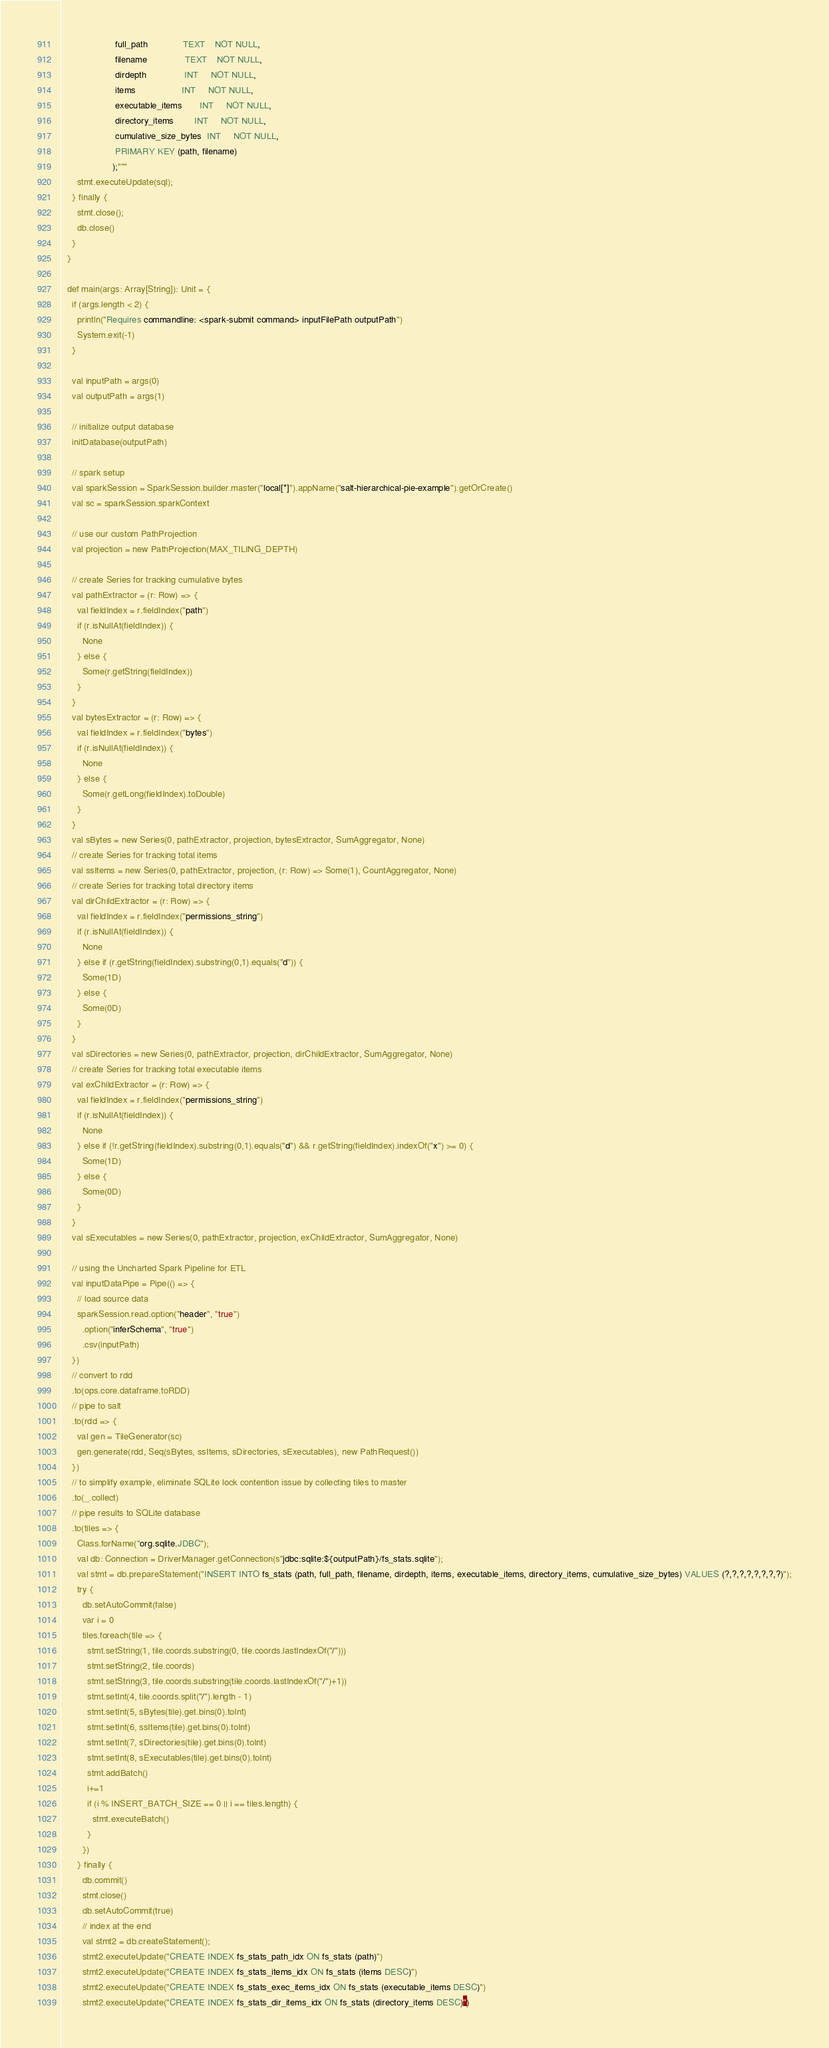Convert code to text. <code><loc_0><loc_0><loc_500><loc_500><_Scala_>                     full_path              TEXT    NOT NULL,
                     filename               TEXT    NOT NULL,
                     dirdepth               INT     NOT NULL,
                     items                  INT     NOT NULL,
                     executable_items       INT     NOT NULL,
                     directory_items        INT     NOT NULL,
                     cumulative_size_bytes  INT     NOT NULL,
                     PRIMARY KEY (path, filename)
                    );"""
      stmt.executeUpdate(sql);
    } finally {
      stmt.close();
      db.close()
    }
  }

  def main(args: Array[String]): Unit = {
    if (args.length < 2) {
      println("Requires commandline: <spark-submit command> inputFilePath outputPath")
      System.exit(-1)
    }

    val inputPath = args(0)
    val outputPath = args(1)

    // initialize output database
    initDatabase(outputPath)

    // spark setup
    val sparkSession = SparkSession.builder.master("local[*]").appName("salt-hierarchical-pie-example").getOrCreate()
    val sc = sparkSession.sparkContext

    // use our custom PathProjection
    val projection = new PathProjection(MAX_TILING_DEPTH)

    // create Series for tracking cumulative bytes
    val pathExtractor = (r: Row) => {
      val fieldIndex = r.fieldIndex("path")
      if (r.isNullAt(fieldIndex)) {
        None
      } else {
        Some(r.getString(fieldIndex))
      }
    }
    val bytesExtractor = (r: Row) => {
      val fieldIndex = r.fieldIndex("bytes")
      if (r.isNullAt(fieldIndex)) {
        None
      } else {
        Some(r.getLong(fieldIndex).toDouble)
      }
    }
    val sBytes = new Series(0, pathExtractor, projection, bytesExtractor, SumAggregator, None)
    // create Series for tracking total items
    val ssItems = new Series(0, pathExtractor, projection, (r: Row) => Some(1), CountAggregator, None)
    // create Series for tracking total directory items
    val dirChildExtractor = (r: Row) => {
      val fieldIndex = r.fieldIndex("permissions_string")
      if (r.isNullAt(fieldIndex)) {
        None
      } else if (r.getString(fieldIndex).substring(0,1).equals("d")) {
        Some(1D)
      } else {
        Some(0D)
      }
    }
    val sDirectories = new Series(0, pathExtractor, projection, dirChildExtractor, SumAggregator, None)
    // create Series for tracking total executable items
    val exChildExtractor = (r: Row) => {
      val fieldIndex = r.fieldIndex("permissions_string")
      if (r.isNullAt(fieldIndex)) {
        None
      } else if (!r.getString(fieldIndex).substring(0,1).equals("d") && r.getString(fieldIndex).indexOf("x") >= 0) {
        Some(1D)
      } else {
        Some(0D)
      }
    }
    val sExecutables = new Series(0, pathExtractor, projection, exChildExtractor, SumAggregator, None)

    // using the Uncharted Spark Pipeline for ETL
    val inputDataPipe = Pipe(() => {
      // load source data
      sparkSession.read.option("header", "true")
        .option("inferSchema", "true")
        .csv(inputPath)
    })
    // convert to rdd
    .to(ops.core.dataframe.toRDD)
    // pipe to salt
    .to(rdd => {
      val gen = TileGenerator(sc)
      gen.generate(rdd, Seq(sBytes, ssItems, sDirectories, sExecutables), new PathRequest())
    })
    // to simplify example, eliminate SQLite lock contention issue by collecting tiles to master
    .to(_.collect)
    // pipe results to SQLite database
    .to(tiles => {
      Class.forName("org.sqlite.JDBC");
      val db: Connection = DriverManager.getConnection(s"jdbc:sqlite:${outputPath}/fs_stats.sqlite");
      val stmt = db.prepareStatement("INSERT INTO fs_stats (path, full_path, filename, dirdepth, items, executable_items, directory_items, cumulative_size_bytes) VALUES (?,?,?,?,?,?,?,?)");
      try {
        db.setAutoCommit(false)
        var i = 0
        tiles.foreach(tile => {
          stmt.setString(1, tile.coords.substring(0, tile.coords.lastIndexOf("/")))
          stmt.setString(2, tile.coords)
          stmt.setString(3, tile.coords.substring(tile.coords.lastIndexOf("/")+1))
          stmt.setInt(4, tile.coords.split("/").length - 1)
          stmt.setInt(5, sBytes(tile).get.bins(0).toInt)
          stmt.setInt(6, ssItems(tile).get.bins(0).toInt)
          stmt.setInt(7, sDirectories(tile).get.bins(0).toInt)
          stmt.setInt(8, sExecutables(tile).get.bins(0).toInt)
          stmt.addBatch()
          i+=1
          if (i % INSERT_BATCH_SIZE == 0 || i == tiles.length) {
            stmt.executeBatch()
          }
        })
      } finally {
        db.commit()
        stmt.close()
        db.setAutoCommit(true)
        // index at the end
        val stmt2 = db.createStatement();
        stmt2.executeUpdate("CREATE INDEX fs_stats_path_idx ON fs_stats (path)")
        stmt2.executeUpdate("CREATE INDEX fs_stats_items_idx ON fs_stats (items DESC)")
        stmt2.executeUpdate("CREATE INDEX fs_stats_exec_items_idx ON fs_stats (executable_items DESC)")
        stmt2.executeUpdate("CREATE INDEX fs_stats_dir_items_idx ON fs_stats (directory_items DESC)")</code> 